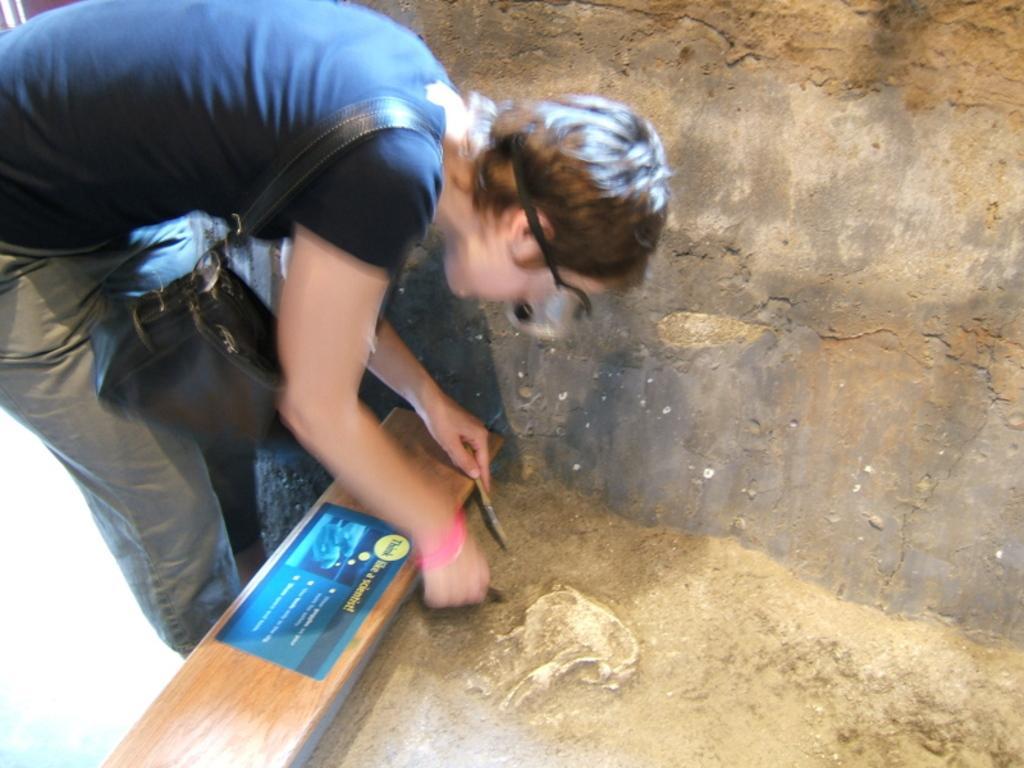Could you give a brief overview of what you see in this image? In this picture there is a woman wearing blue color T shirt and a black color hand bag on the shoulder. In front of her there is a wooden plank. We can observe bones here. In the background there is a wall. 